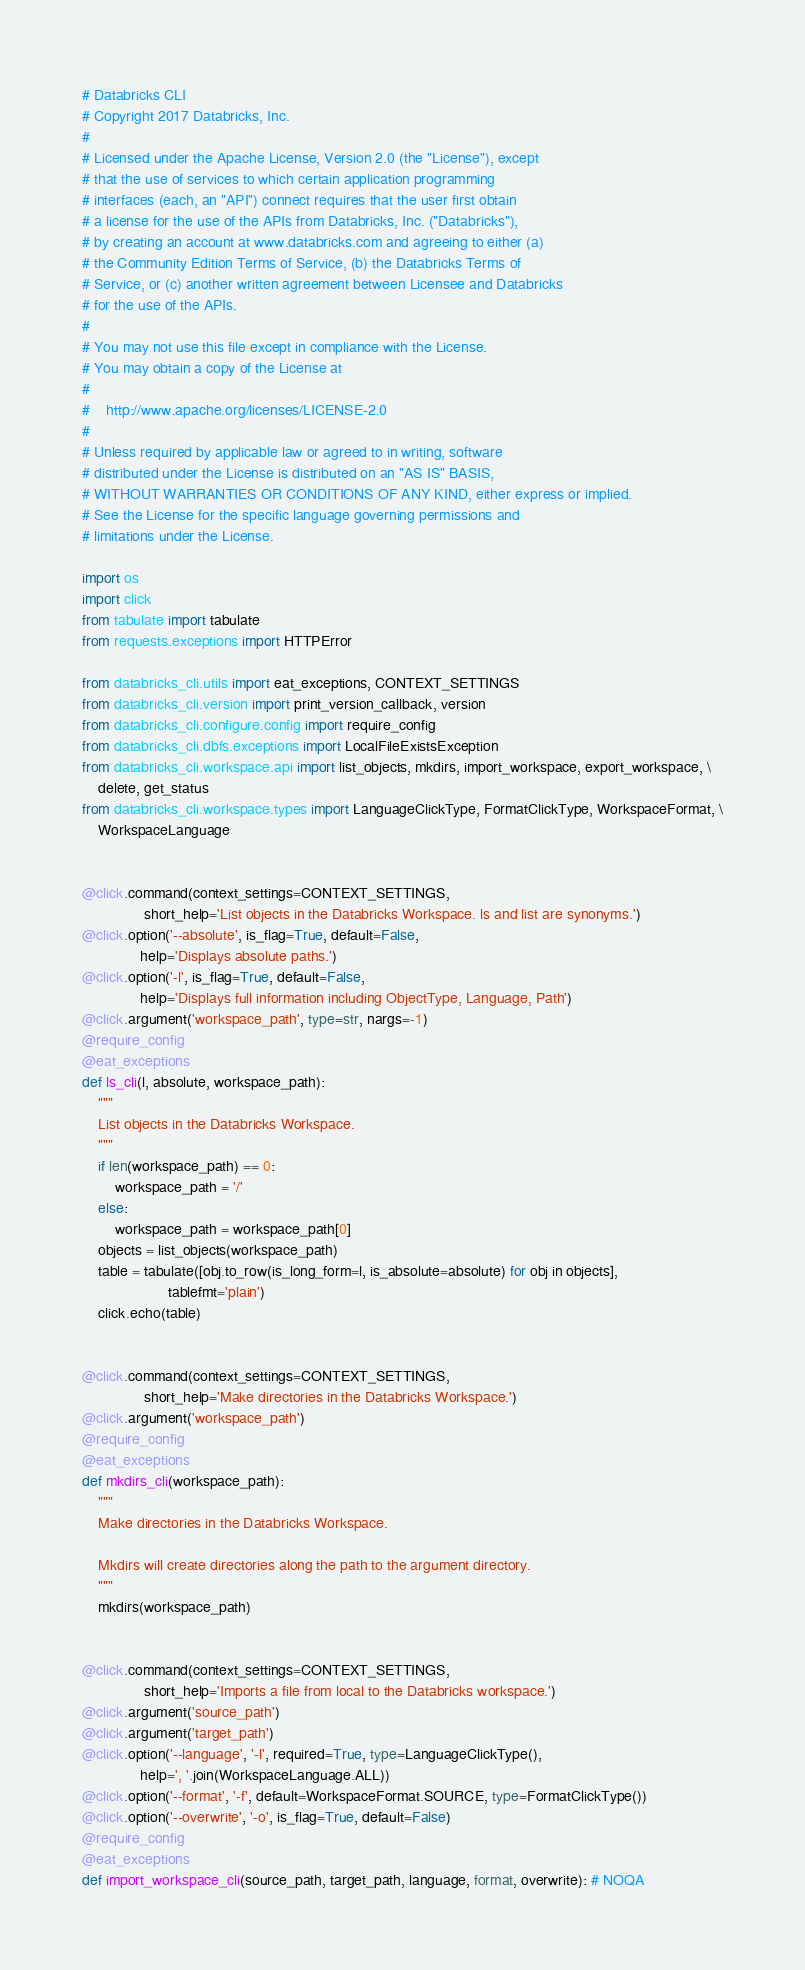<code> <loc_0><loc_0><loc_500><loc_500><_Python_># Databricks CLI
# Copyright 2017 Databricks, Inc.
#
# Licensed under the Apache License, Version 2.0 (the "License"), except
# that the use of services to which certain application programming
# interfaces (each, an "API") connect requires that the user first obtain
# a license for the use of the APIs from Databricks, Inc. ("Databricks"),
# by creating an account at www.databricks.com and agreeing to either (a)
# the Community Edition Terms of Service, (b) the Databricks Terms of
# Service, or (c) another written agreement between Licensee and Databricks
# for the use of the APIs.
#
# You may not use this file except in compliance with the License.
# You may obtain a copy of the License at
#
#    http://www.apache.org/licenses/LICENSE-2.0
#
# Unless required by applicable law or agreed to in writing, software
# distributed under the License is distributed on an "AS IS" BASIS,
# WITHOUT WARRANTIES OR CONDITIONS OF ANY KIND, either express or implied.
# See the License for the specific language governing permissions and
# limitations under the License.

import os
import click
from tabulate import tabulate
from requests.exceptions import HTTPError

from databricks_cli.utils import eat_exceptions, CONTEXT_SETTINGS
from databricks_cli.version import print_version_callback, version
from databricks_cli.configure.config import require_config
from databricks_cli.dbfs.exceptions import LocalFileExistsException
from databricks_cli.workspace.api import list_objects, mkdirs, import_workspace, export_workspace, \
    delete, get_status
from databricks_cli.workspace.types import LanguageClickType, FormatClickType, WorkspaceFormat, \
    WorkspaceLanguage


@click.command(context_settings=CONTEXT_SETTINGS,
               short_help='List objects in the Databricks Workspace. ls and list are synonyms.')
@click.option('--absolute', is_flag=True, default=False,
              help='Displays absolute paths.')
@click.option('-l', is_flag=True, default=False,
              help='Displays full information including ObjectType, Language, Path')
@click.argument('workspace_path', type=str, nargs=-1)
@require_config
@eat_exceptions
def ls_cli(l, absolute, workspace_path):
    """
    List objects in the Databricks Workspace.
    """
    if len(workspace_path) == 0:
        workspace_path = '/'
    else:
        workspace_path = workspace_path[0]
    objects = list_objects(workspace_path)
    table = tabulate([obj.to_row(is_long_form=l, is_absolute=absolute) for obj in objects],
                     tablefmt='plain')
    click.echo(table)


@click.command(context_settings=CONTEXT_SETTINGS,
               short_help='Make directories in the Databricks Workspace.')
@click.argument('workspace_path')
@require_config
@eat_exceptions
def mkdirs_cli(workspace_path):
    """
    Make directories in the Databricks Workspace.

    Mkdirs will create directories along the path to the argument directory.
    """
    mkdirs(workspace_path)


@click.command(context_settings=CONTEXT_SETTINGS,
               short_help='Imports a file from local to the Databricks workspace.')
@click.argument('source_path')
@click.argument('target_path')
@click.option('--language', '-l', required=True, type=LanguageClickType(),
              help=', '.join(WorkspaceLanguage.ALL))
@click.option('--format', '-f', default=WorkspaceFormat.SOURCE, type=FormatClickType())
@click.option('--overwrite', '-o', is_flag=True, default=False)
@require_config
@eat_exceptions
def import_workspace_cli(source_path, target_path, language, format, overwrite): # NOQA</code> 